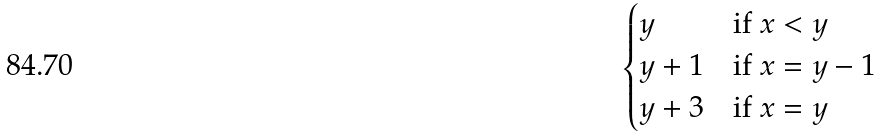<formula> <loc_0><loc_0><loc_500><loc_500>\begin{cases} y & \text {if } x < y \\ y + 1 & \text {if } x = y - 1 \\ y + 3 & \text {if } x = y \end{cases}</formula> 